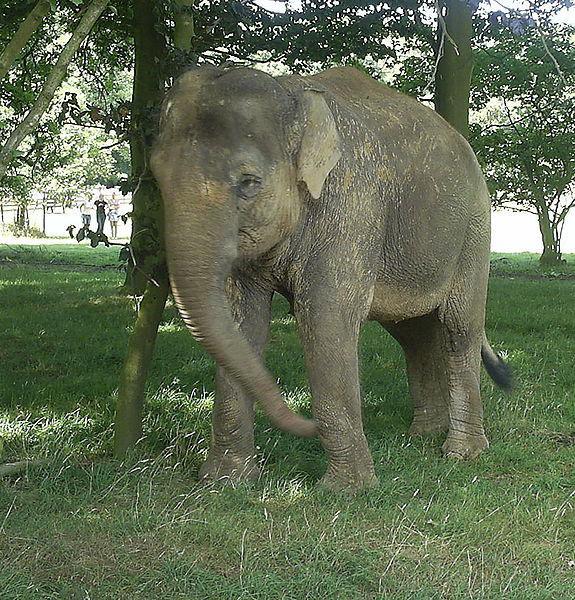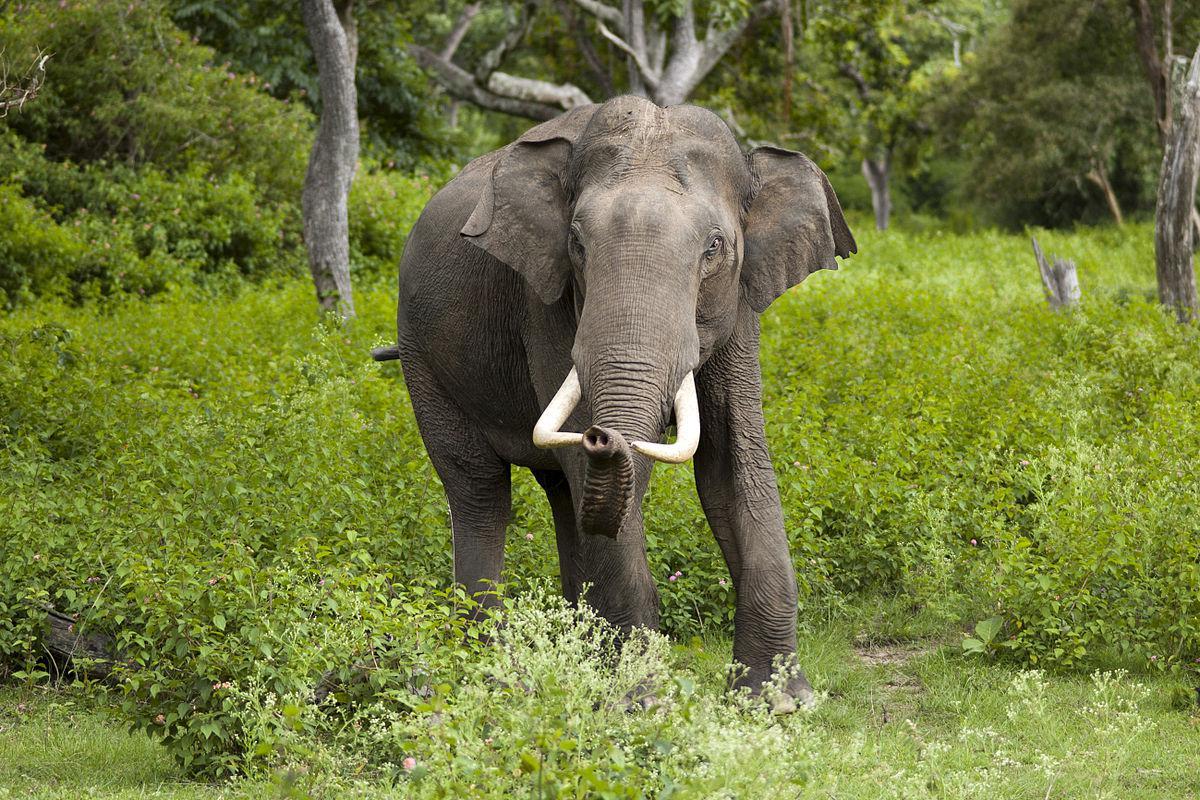The first image is the image on the left, the second image is the image on the right. Examine the images to the left and right. Is the description "At least one image is exactly one baby elephant standing between two adults." accurate? Answer yes or no. No. 